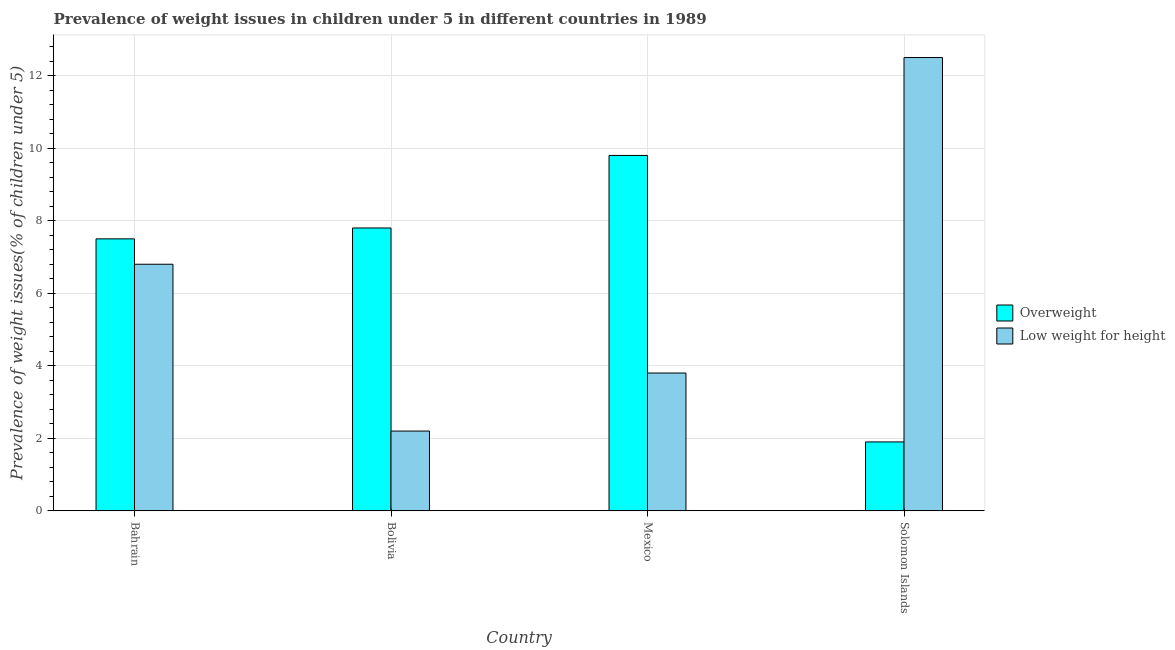How many different coloured bars are there?
Your answer should be compact. 2. How many groups of bars are there?
Your answer should be very brief. 4. Are the number of bars per tick equal to the number of legend labels?
Ensure brevity in your answer.  Yes. How many bars are there on the 3rd tick from the right?
Make the answer very short. 2. What is the label of the 4th group of bars from the left?
Offer a very short reply. Solomon Islands. What is the percentage of overweight children in Bolivia?
Offer a terse response. 7.8. Across all countries, what is the maximum percentage of overweight children?
Your answer should be compact. 9.8. Across all countries, what is the minimum percentage of underweight children?
Keep it short and to the point. 2.2. In which country was the percentage of underweight children maximum?
Provide a succinct answer. Solomon Islands. In which country was the percentage of overweight children minimum?
Keep it short and to the point. Solomon Islands. What is the total percentage of underweight children in the graph?
Make the answer very short. 25.3. What is the difference between the percentage of overweight children in Bahrain and that in Mexico?
Give a very brief answer. -2.3. What is the difference between the percentage of underweight children in Mexico and the percentage of overweight children in Bolivia?
Provide a short and direct response. -4. What is the average percentage of underweight children per country?
Keep it short and to the point. 6.33. What is the difference between the percentage of underweight children and percentage of overweight children in Mexico?
Keep it short and to the point. -6. What is the ratio of the percentage of overweight children in Bolivia to that in Mexico?
Provide a short and direct response. 0.8. Is the difference between the percentage of underweight children in Bolivia and Solomon Islands greater than the difference between the percentage of overweight children in Bolivia and Solomon Islands?
Provide a succinct answer. No. What is the difference between the highest and the second highest percentage of overweight children?
Make the answer very short. 2. What is the difference between the highest and the lowest percentage of underweight children?
Your answer should be compact. 10.3. In how many countries, is the percentage of underweight children greater than the average percentage of underweight children taken over all countries?
Make the answer very short. 2. What does the 2nd bar from the left in Bahrain represents?
Give a very brief answer. Low weight for height. What does the 2nd bar from the right in Solomon Islands represents?
Keep it short and to the point. Overweight. How many bars are there?
Your answer should be very brief. 8. Are all the bars in the graph horizontal?
Ensure brevity in your answer.  No. What is the difference between two consecutive major ticks on the Y-axis?
Offer a terse response. 2. Are the values on the major ticks of Y-axis written in scientific E-notation?
Your response must be concise. No. Does the graph contain any zero values?
Your answer should be very brief. No. Does the graph contain grids?
Offer a very short reply. Yes. How many legend labels are there?
Keep it short and to the point. 2. What is the title of the graph?
Your answer should be compact. Prevalence of weight issues in children under 5 in different countries in 1989. What is the label or title of the X-axis?
Keep it short and to the point. Country. What is the label or title of the Y-axis?
Offer a terse response. Prevalence of weight issues(% of children under 5). What is the Prevalence of weight issues(% of children under 5) of Overweight in Bahrain?
Keep it short and to the point. 7.5. What is the Prevalence of weight issues(% of children under 5) in Low weight for height in Bahrain?
Make the answer very short. 6.8. What is the Prevalence of weight issues(% of children under 5) in Overweight in Bolivia?
Provide a short and direct response. 7.8. What is the Prevalence of weight issues(% of children under 5) in Low weight for height in Bolivia?
Your answer should be very brief. 2.2. What is the Prevalence of weight issues(% of children under 5) in Overweight in Mexico?
Keep it short and to the point. 9.8. What is the Prevalence of weight issues(% of children under 5) of Low weight for height in Mexico?
Ensure brevity in your answer.  3.8. What is the Prevalence of weight issues(% of children under 5) in Overweight in Solomon Islands?
Keep it short and to the point. 1.9. Across all countries, what is the maximum Prevalence of weight issues(% of children under 5) in Overweight?
Offer a terse response. 9.8. Across all countries, what is the minimum Prevalence of weight issues(% of children under 5) in Overweight?
Provide a succinct answer. 1.9. Across all countries, what is the minimum Prevalence of weight issues(% of children under 5) in Low weight for height?
Offer a very short reply. 2.2. What is the total Prevalence of weight issues(% of children under 5) of Low weight for height in the graph?
Ensure brevity in your answer.  25.3. What is the difference between the Prevalence of weight issues(% of children under 5) of Overweight in Bahrain and that in Bolivia?
Give a very brief answer. -0.3. What is the difference between the Prevalence of weight issues(% of children under 5) in Overweight in Bahrain and that in Solomon Islands?
Ensure brevity in your answer.  5.6. What is the difference between the Prevalence of weight issues(% of children under 5) of Low weight for height in Bolivia and that in Mexico?
Your answer should be compact. -1.6. What is the difference between the Prevalence of weight issues(% of children under 5) in Low weight for height in Bolivia and that in Solomon Islands?
Ensure brevity in your answer.  -10.3. What is the difference between the Prevalence of weight issues(% of children under 5) in Overweight in Mexico and that in Solomon Islands?
Provide a succinct answer. 7.9. What is the difference between the Prevalence of weight issues(% of children under 5) of Low weight for height in Mexico and that in Solomon Islands?
Your answer should be very brief. -8.7. What is the difference between the Prevalence of weight issues(% of children under 5) of Overweight in Bahrain and the Prevalence of weight issues(% of children under 5) of Low weight for height in Bolivia?
Your answer should be very brief. 5.3. What is the difference between the Prevalence of weight issues(% of children under 5) of Overweight in Bahrain and the Prevalence of weight issues(% of children under 5) of Low weight for height in Mexico?
Keep it short and to the point. 3.7. What is the difference between the Prevalence of weight issues(% of children under 5) in Overweight in Bolivia and the Prevalence of weight issues(% of children under 5) in Low weight for height in Solomon Islands?
Your response must be concise. -4.7. What is the difference between the Prevalence of weight issues(% of children under 5) of Overweight in Mexico and the Prevalence of weight issues(% of children under 5) of Low weight for height in Solomon Islands?
Your response must be concise. -2.7. What is the average Prevalence of weight issues(% of children under 5) in Overweight per country?
Provide a succinct answer. 6.75. What is the average Prevalence of weight issues(% of children under 5) in Low weight for height per country?
Your answer should be compact. 6.33. What is the difference between the Prevalence of weight issues(% of children under 5) in Overweight and Prevalence of weight issues(% of children under 5) in Low weight for height in Bahrain?
Your response must be concise. 0.7. What is the ratio of the Prevalence of weight issues(% of children under 5) of Overweight in Bahrain to that in Bolivia?
Offer a very short reply. 0.96. What is the ratio of the Prevalence of weight issues(% of children under 5) of Low weight for height in Bahrain to that in Bolivia?
Provide a succinct answer. 3.09. What is the ratio of the Prevalence of weight issues(% of children under 5) in Overweight in Bahrain to that in Mexico?
Make the answer very short. 0.77. What is the ratio of the Prevalence of weight issues(% of children under 5) of Low weight for height in Bahrain to that in Mexico?
Offer a terse response. 1.79. What is the ratio of the Prevalence of weight issues(% of children under 5) of Overweight in Bahrain to that in Solomon Islands?
Make the answer very short. 3.95. What is the ratio of the Prevalence of weight issues(% of children under 5) of Low weight for height in Bahrain to that in Solomon Islands?
Make the answer very short. 0.54. What is the ratio of the Prevalence of weight issues(% of children under 5) in Overweight in Bolivia to that in Mexico?
Provide a succinct answer. 0.8. What is the ratio of the Prevalence of weight issues(% of children under 5) of Low weight for height in Bolivia to that in Mexico?
Your response must be concise. 0.58. What is the ratio of the Prevalence of weight issues(% of children under 5) in Overweight in Bolivia to that in Solomon Islands?
Ensure brevity in your answer.  4.11. What is the ratio of the Prevalence of weight issues(% of children under 5) of Low weight for height in Bolivia to that in Solomon Islands?
Your answer should be very brief. 0.18. What is the ratio of the Prevalence of weight issues(% of children under 5) in Overweight in Mexico to that in Solomon Islands?
Provide a succinct answer. 5.16. What is the ratio of the Prevalence of weight issues(% of children under 5) in Low weight for height in Mexico to that in Solomon Islands?
Offer a terse response. 0.3. What is the difference between the highest and the second highest Prevalence of weight issues(% of children under 5) in Overweight?
Your response must be concise. 2. What is the difference between the highest and the lowest Prevalence of weight issues(% of children under 5) in Overweight?
Keep it short and to the point. 7.9. What is the difference between the highest and the lowest Prevalence of weight issues(% of children under 5) of Low weight for height?
Give a very brief answer. 10.3. 